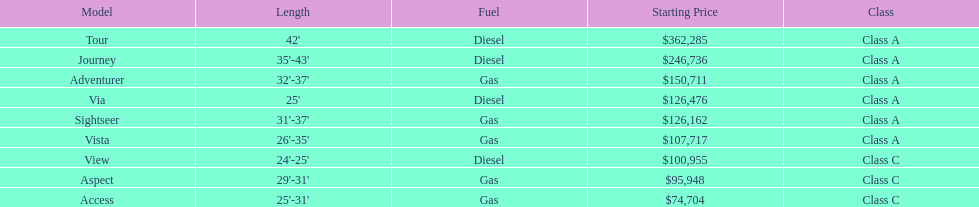What is the price of bot the via and tour models combined? $488,761. 